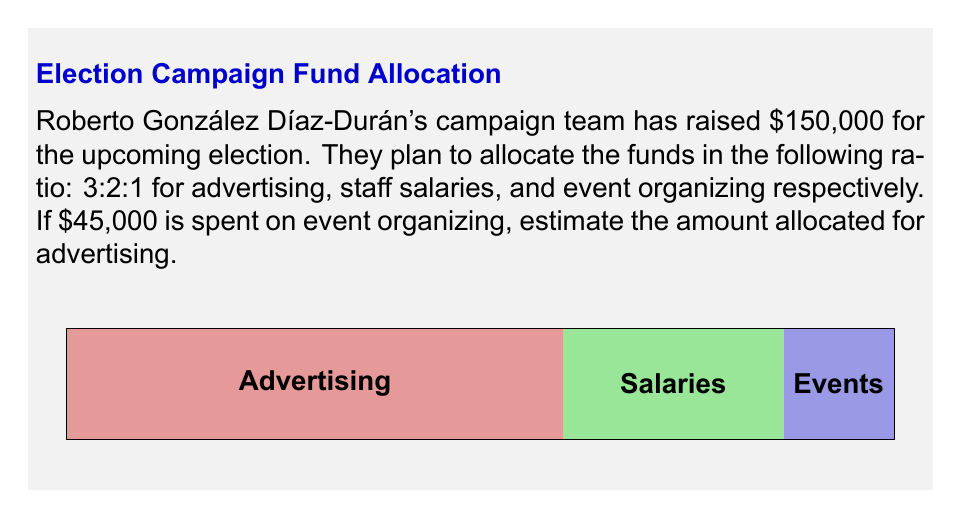Teach me how to tackle this problem. Let's solve this step-by-step:

1) First, we need to understand the ratio given: 3:2:1 for advertising, staff salaries, and event organizing.

2) The total parts in this ratio is $3 + 2 + 1 = 6$ parts.

3) We know that $45,000 is spent on event organizing, which represents 1 part of the ratio.

4) To find the value of one part, we can set up the following equation:
   $1x = 45,000$
   $x = 45,000$

5) Now that we know one part equals $45,000, we can find the total budget:
   Total budget = $6x = 6 * 45,000 = 270,000$

6) The question asks for the amount allocated to advertising, which is 3 parts of the ratio.

7) To calculate this, we multiply the value of one part by 3:
   Advertising budget = $3x = 3 * 45,000 = 135,000$

Therefore, the estimated amount allocated for advertising is $135,000.
Answer: $135,000 